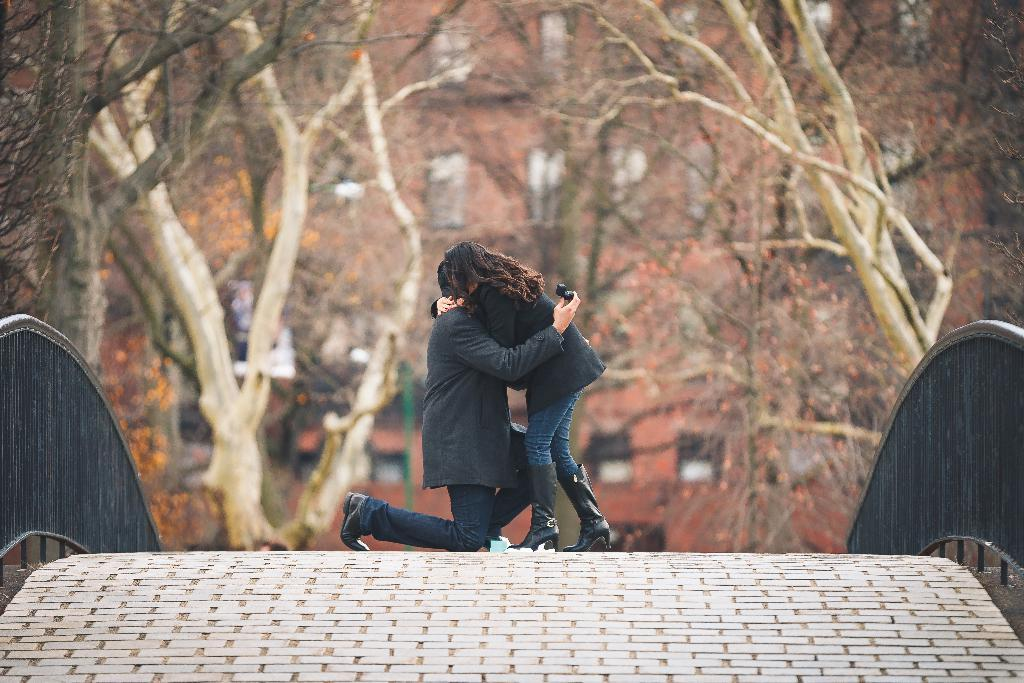How many people are in the image? There are two people in the image. Where are the people located in the image? The people are on a bridge. What can be seen in the background of the image? There are trees and buildings visible in the background of the image. What type of notebook is the bird carrying in the image? There is no bird or notebook present in the image. How far away are the buildings from the people in the image? The distance between the people and the buildings cannot be determined from the image alone. 